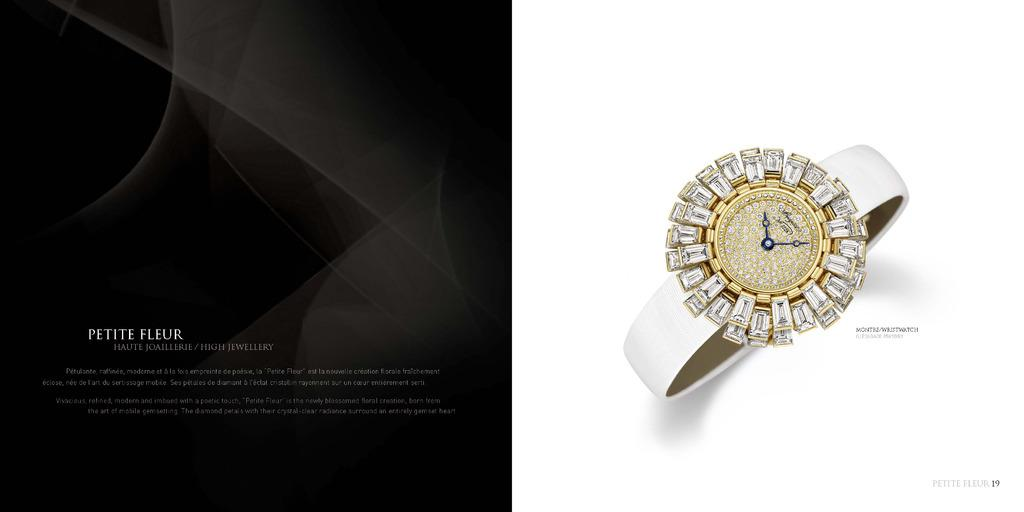<image>
Give a short and clear explanation of the subsequent image. An ad for Petite Fleur features a woman's watch. 